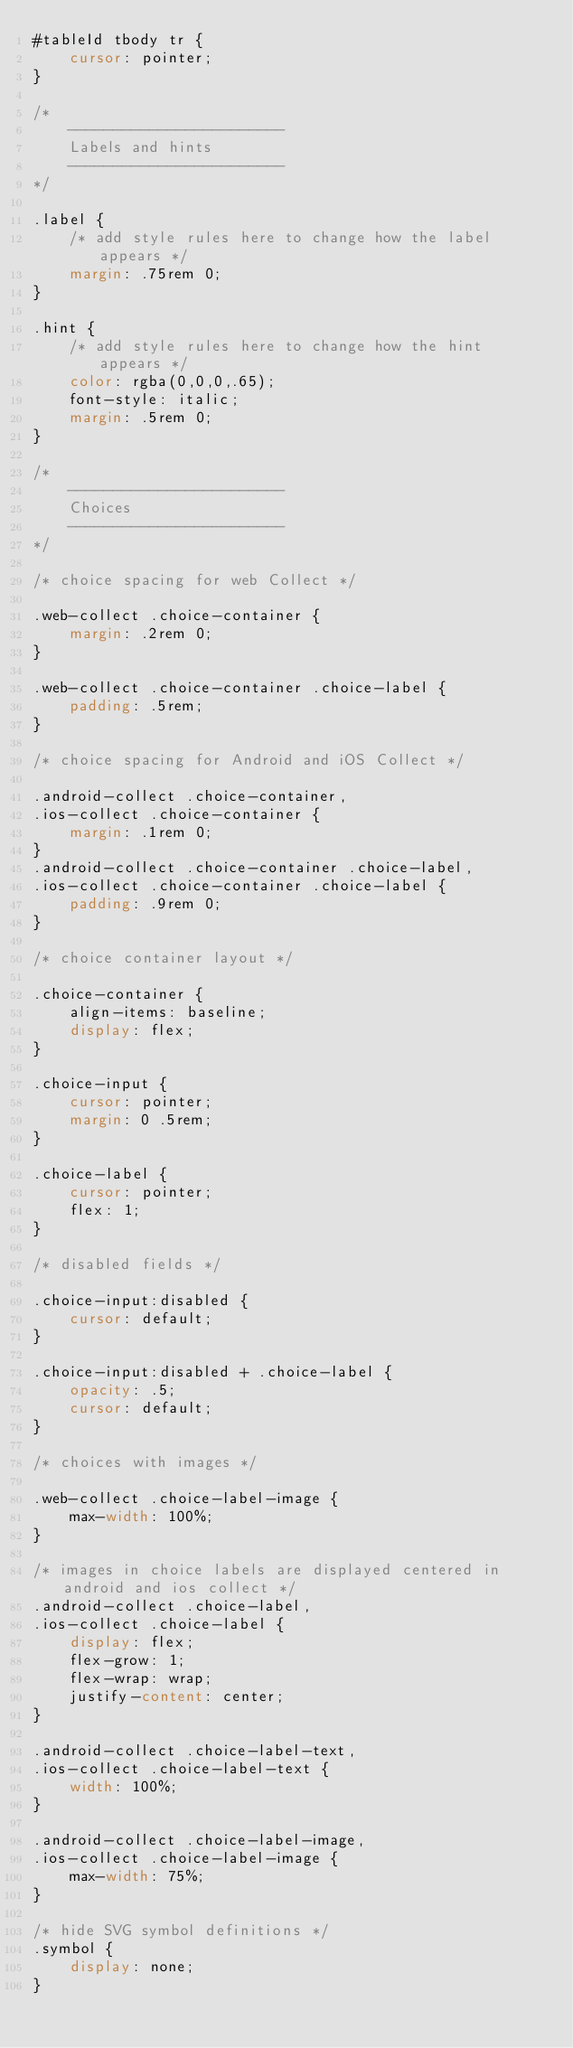Convert code to text. <code><loc_0><loc_0><loc_500><loc_500><_CSS_>#tableId tbody tr {
    cursor: pointer; 
}

/*
    ------------------------
    Labels and hints
    ------------------------
*/

.label {
    /* add style rules here to change how the label appears */
    margin: .75rem 0;
}

.hint {
    /* add style rules here to change how the hint appears */
    color: rgba(0,0,0,.65);
    font-style: italic;
    margin: .5rem 0;
}

/* 
    ------------------------
    Choices
    ------------------------
*/

/* choice spacing for web Collect */

.web-collect .choice-container {
    margin: .2rem 0;
}

.web-collect .choice-container .choice-label {
    padding: .5rem;
}

/* choice spacing for Android and iOS Collect */

.android-collect .choice-container,
.ios-collect .choice-container {
    margin: .1rem 0;
}
.android-collect .choice-container .choice-label,
.ios-collect .choice-container .choice-label {
    padding: .9rem 0;
}

/* choice container layout */

.choice-container {
    align-items: baseline;
    display: flex;
}

.choice-input {
    cursor: pointer;
    margin: 0 .5rem;
}

.choice-label {
    cursor: pointer;
    flex: 1;
}

/* disabled fields */

.choice-input:disabled {
    cursor: default;
}

.choice-input:disabled + .choice-label {
    opacity: .5;
    cursor: default;
}

/* choices with images */

.web-collect .choice-label-image {
    max-width: 100%;
}

/* images in choice labels are displayed centered in android and ios collect */
.android-collect .choice-label,
.ios-collect .choice-label {
    display: flex;
    flex-grow: 1;
    flex-wrap: wrap;
    justify-content: center;
}

.android-collect .choice-label-text,
.ios-collect .choice-label-text {
    width: 100%;
}

.android-collect .choice-label-image,
.ios-collect .choice-label-image {
    max-width: 75%;
}

/* hide SVG symbol definitions */
.symbol {
    display: none;
}</code> 